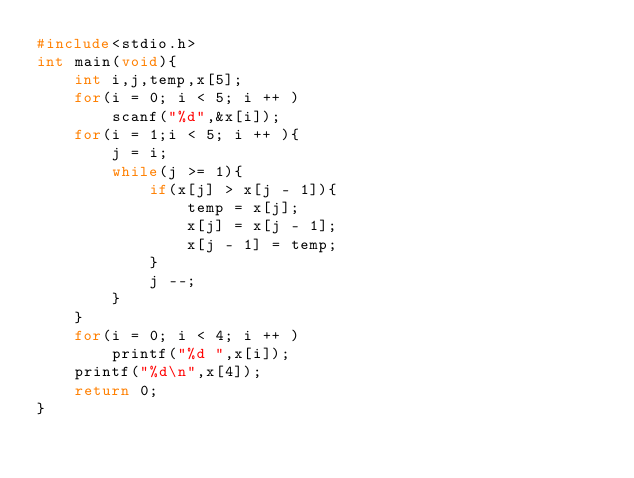Convert code to text. <code><loc_0><loc_0><loc_500><loc_500><_C_>#include<stdio.h>
int main(void){
    int i,j,temp,x[5];
    for(i = 0; i < 5; i ++ )
        scanf("%d",&x[i]);
    for(i = 1;i < 5; i ++ ){
        j = i;
        while(j >= 1){
            if(x[j] > x[j - 1]){
                temp = x[j];
                x[j] = x[j - 1];
                x[j - 1] = temp;
            }
            j --;
        }
    }
    for(i = 0; i < 4; i ++ )
        printf("%d ",x[i]);
    printf("%d\n",x[4]);
    return 0;
}
</code> 